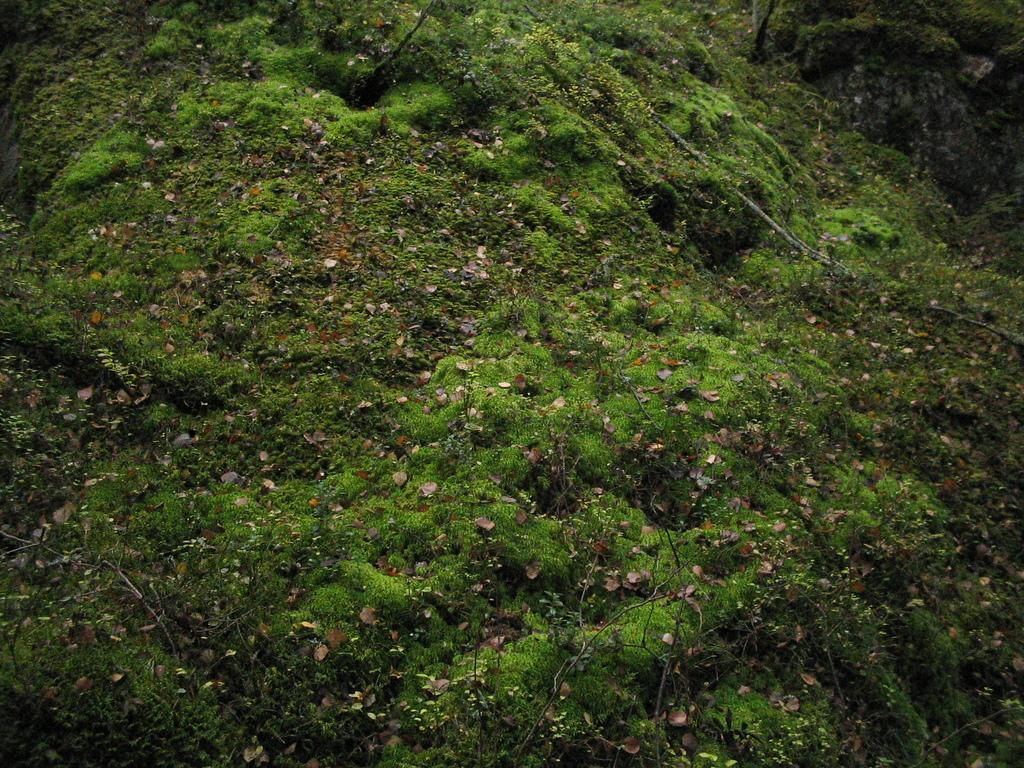What type of vegetation is present on the ground in the image? There is grass on the ground in the image. What else can be seen on the ground in the image besides grass? There are leaves on the ground in the image. What type of heart-shaped ice sculpture can be seen in the image? There is no heart-shaped ice sculpture present in the image; it only features grass and leaves on the ground. 